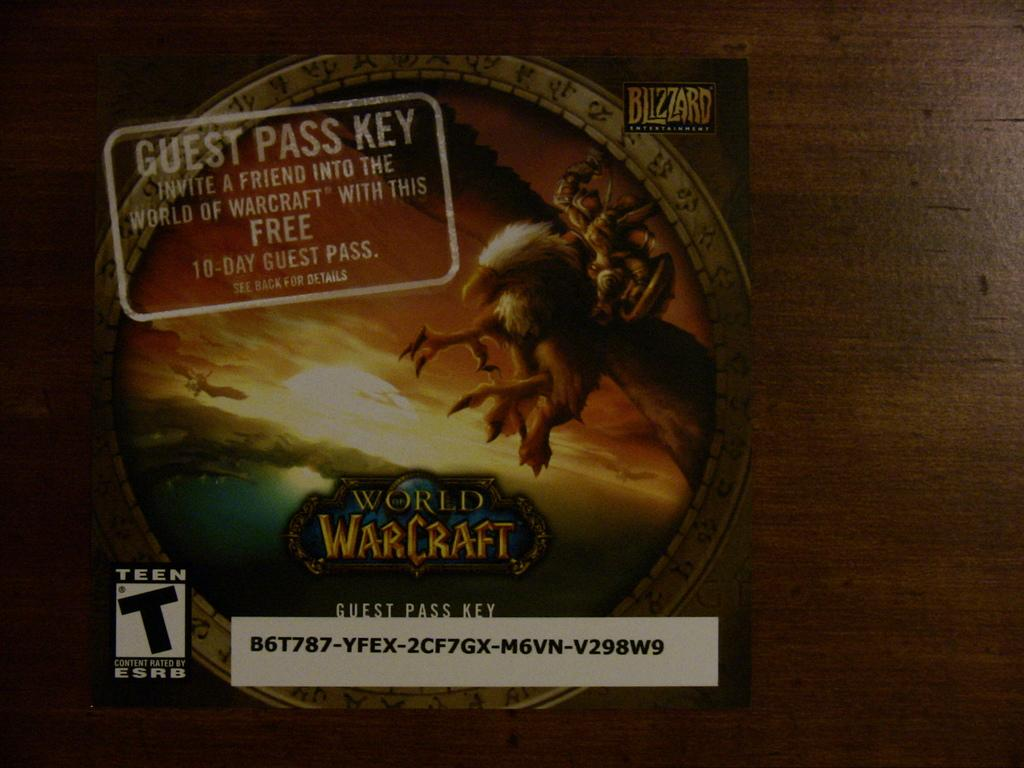<image>
Write a terse but informative summary of the picture. the guest pass key for world of warcraft is rated for teens 